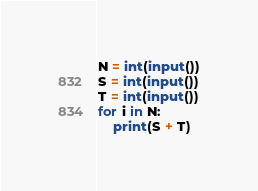<code> <loc_0><loc_0><loc_500><loc_500><_Python_>N = int(input())
S = int(input())
T = int(input())
for i in N:
    print(S + T)
</code> 